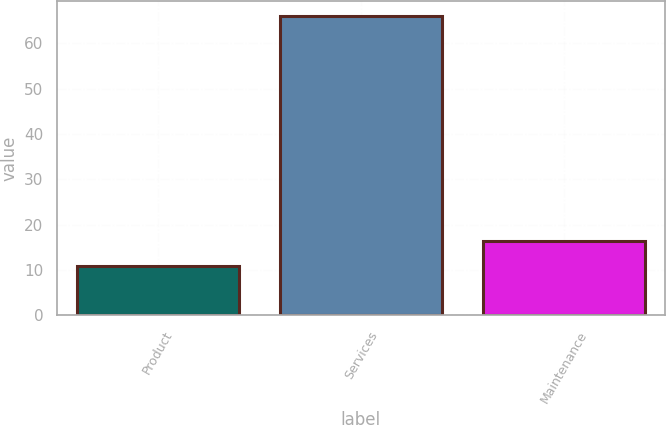Convert chart to OTSL. <chart><loc_0><loc_0><loc_500><loc_500><bar_chart><fcel>Product<fcel>Services<fcel>Maintenance<nl><fcel>11<fcel>66<fcel>16.5<nl></chart> 